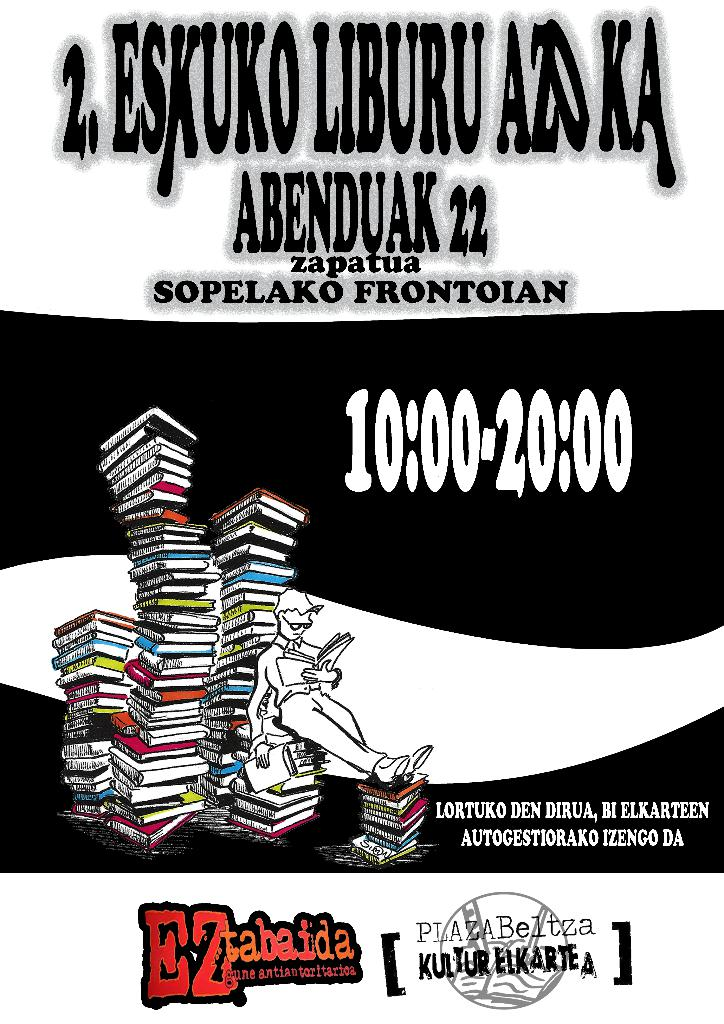Describe the artistic style used in the poster. The poster utilizes a bold and dynamic artistic style, featuring a monochrome backdrop with a central figure in a simplistic, cartoon-like drawing, reading on a vibrant stack of books. This style emphasizes the themes of reading and knowledge. 